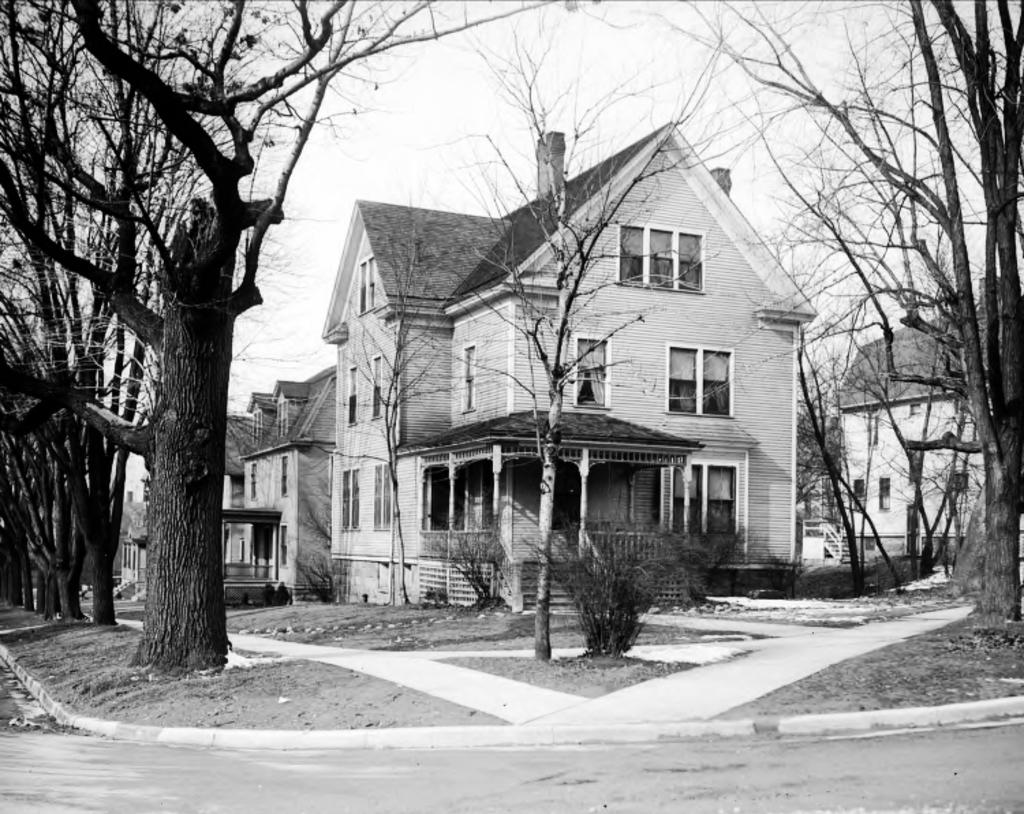What type of natural elements can be seen in the image? There are trees in the image. What type of man-made structures are present in the image? There are buildings in the image. What type of vegetation is present on the ground in the image? There are plants on the ground in the image. What is the condition of the sky in the image? The sky is clear in the image. What color scheme is used in the image? The image is in black and white color. Can you tell me how many cars are parked under the trees in the image? There are no cars present in the image; it features trees, buildings, plants, and a clear sky in black and white color. What type of stomach ailment is depicted in the image? There is no stomach or any ailment related to it present in the image. 